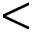Convert formula to latex. <formula><loc_0><loc_0><loc_500><loc_500><</formula> 